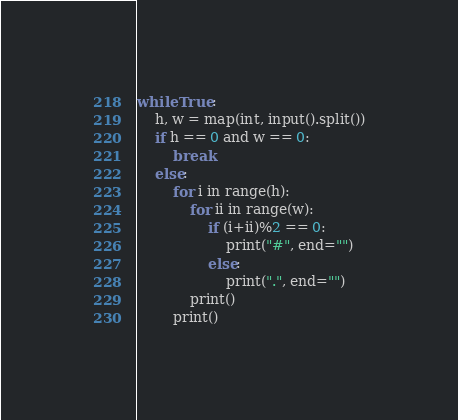Convert code to text. <code><loc_0><loc_0><loc_500><loc_500><_Python_>while True:
    h, w = map(int, input().split())
    if h == 0 and w == 0:
        break
    else:
        for i in range(h):
            for ii in range(w):
                if (i+ii)%2 == 0:
                    print("#", end="")
                else:
                    print(".", end="")
            print()
        print()
</code> 